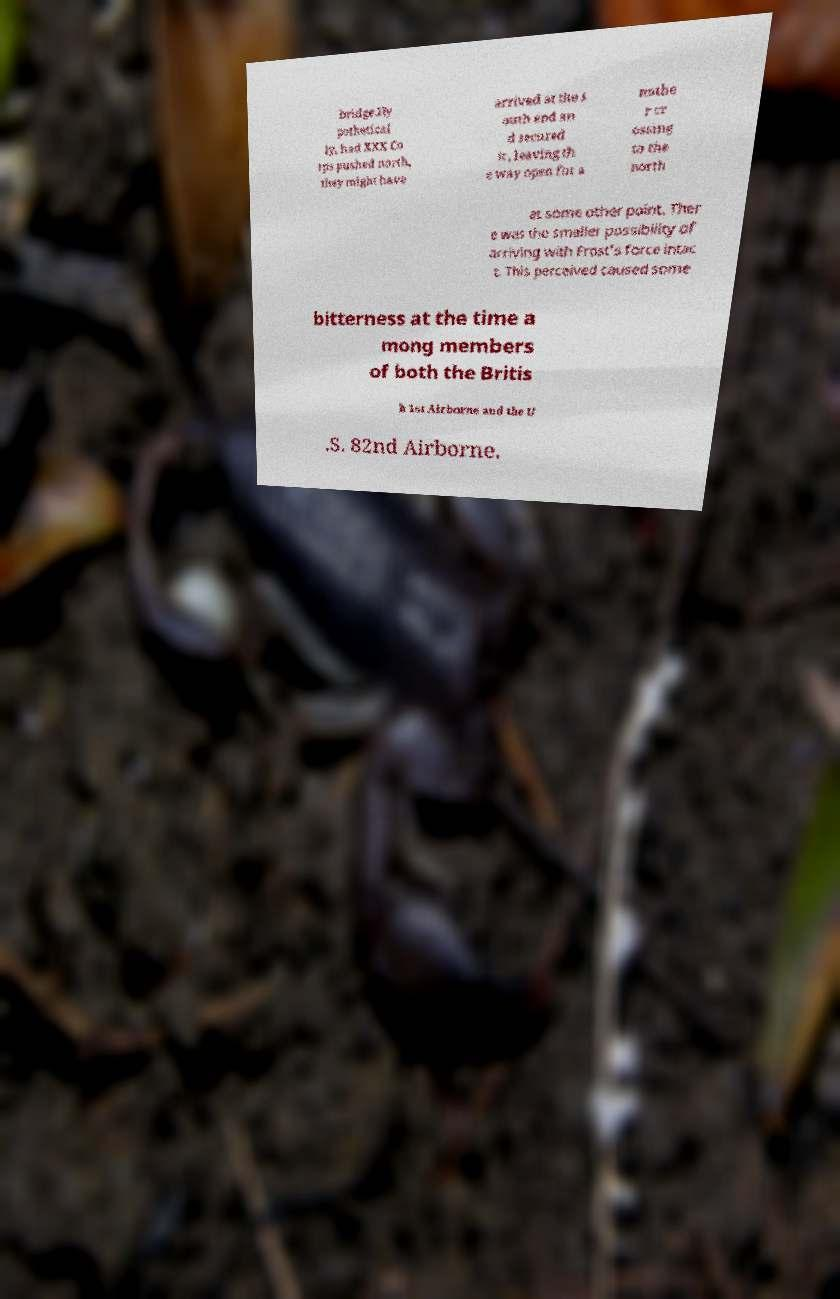Can you read and provide the text displayed in the image?This photo seems to have some interesting text. Can you extract and type it out for me? bridge.Hy pothetical ly, had XXX Co rps pushed north, they might have arrived at the s outh end an d secured it , leaving th e way open for a nothe r cr ossing to the north at some other point. Ther e was the smaller possibility of arriving with Frost's force intac t. This perceived caused some bitterness at the time a mong members of both the Britis h 1st Airborne and the U .S. 82nd Airborne. 